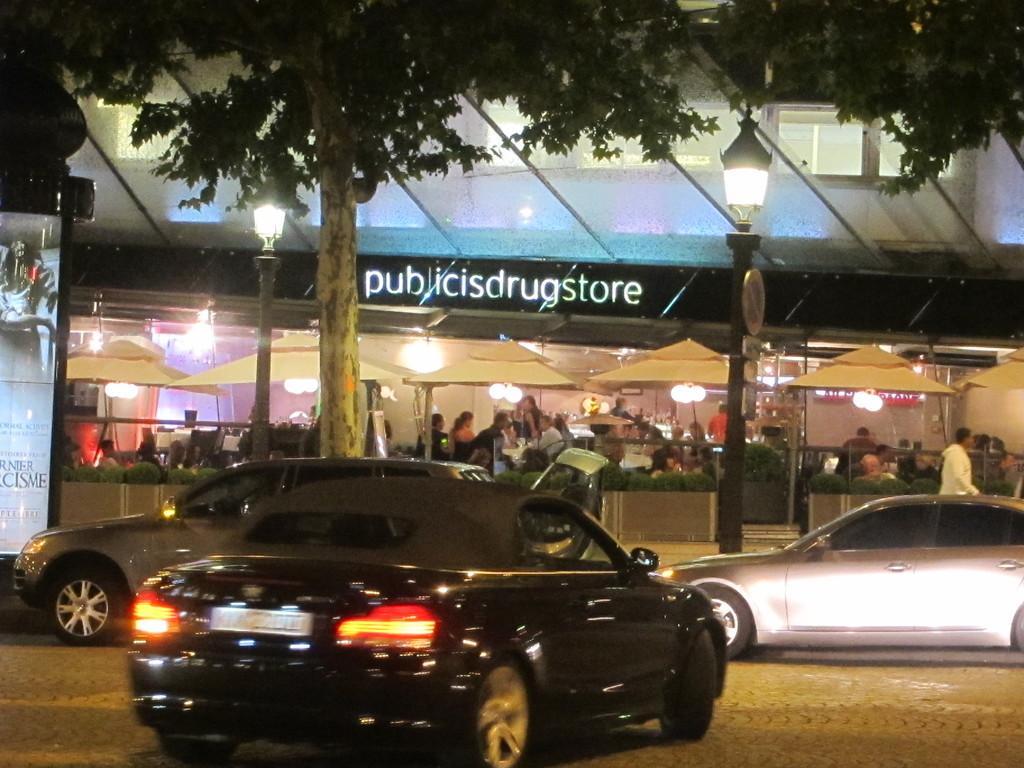Please provide a concise description of this image. We can see trees,cars,board and lights on poles. In the background we can see building,plant,lights and people. 